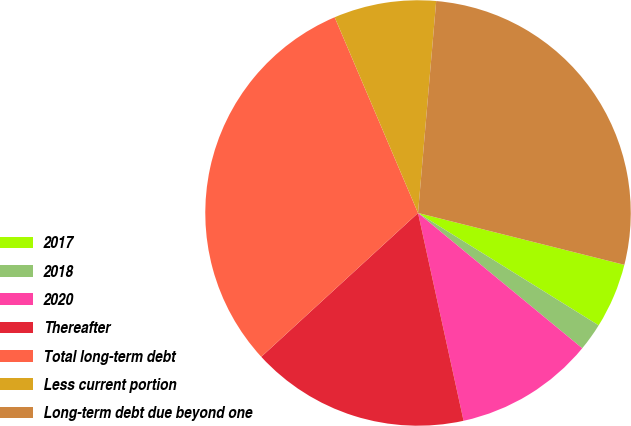Convert chart. <chart><loc_0><loc_0><loc_500><loc_500><pie_chart><fcel>2017<fcel>2018<fcel>2020<fcel>Thereafter<fcel>Total long-term debt<fcel>Less current portion<fcel>Long-term debt due beyond one<nl><fcel>4.94%<fcel>2.11%<fcel>10.6%<fcel>16.62%<fcel>30.41%<fcel>7.77%<fcel>27.56%<nl></chart> 